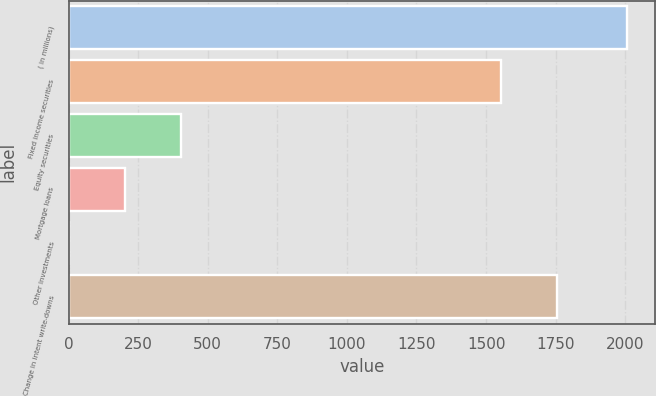Convert chart. <chart><loc_0><loc_0><loc_500><loc_500><bar_chart><fcel>( in millions)<fcel>Fixed income securities<fcel>Equity securities<fcel>Mortgage loans<fcel>Other investments<fcel>Change in intent write-downs<nl><fcel>2008<fcel>1555<fcel>404<fcel>203.5<fcel>3<fcel>1755.5<nl></chart> 